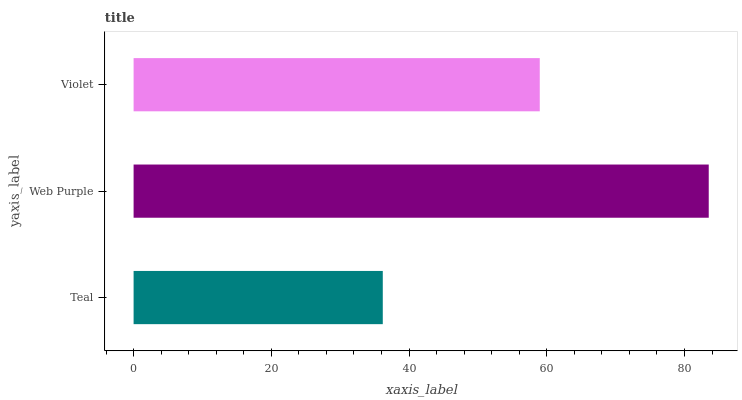Is Teal the minimum?
Answer yes or no. Yes. Is Web Purple the maximum?
Answer yes or no. Yes. Is Violet the minimum?
Answer yes or no. No. Is Violet the maximum?
Answer yes or no. No. Is Web Purple greater than Violet?
Answer yes or no. Yes. Is Violet less than Web Purple?
Answer yes or no. Yes. Is Violet greater than Web Purple?
Answer yes or no. No. Is Web Purple less than Violet?
Answer yes or no. No. Is Violet the high median?
Answer yes or no. Yes. Is Violet the low median?
Answer yes or no. Yes. Is Web Purple the high median?
Answer yes or no. No. Is Web Purple the low median?
Answer yes or no. No. 